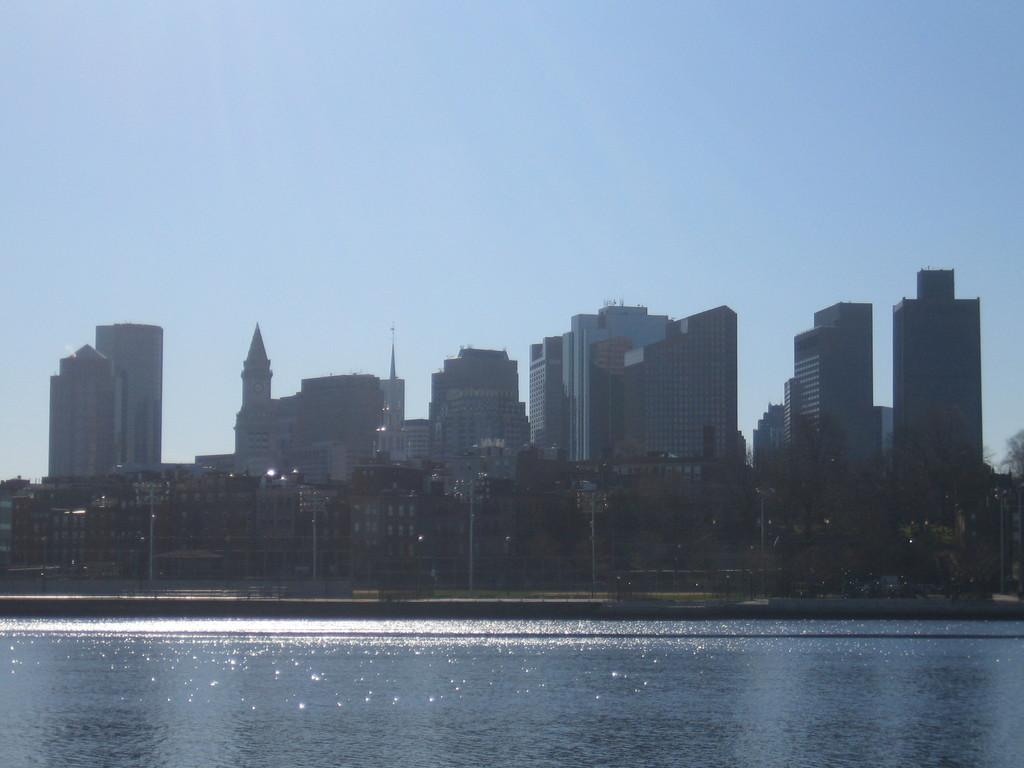What type of location is depicted in the image? The image is an outside view. What natural feature can be seen at the bottom of the image? There is a sea at the bottom of the image. What type of vegetation is visible in the background of the image? There are many trees in the background of the image. What man-made structures can be seen in the background of the image? There are poles and buildings in the background of the image. What is visible at the top of the image? The sky is visible at the top of the image. What type of arch can be seen in the image? There is no arch present in the image. What type of wax is used to create the buildings in the image? There is no wax used to create the buildings in the image; they are real structures. 